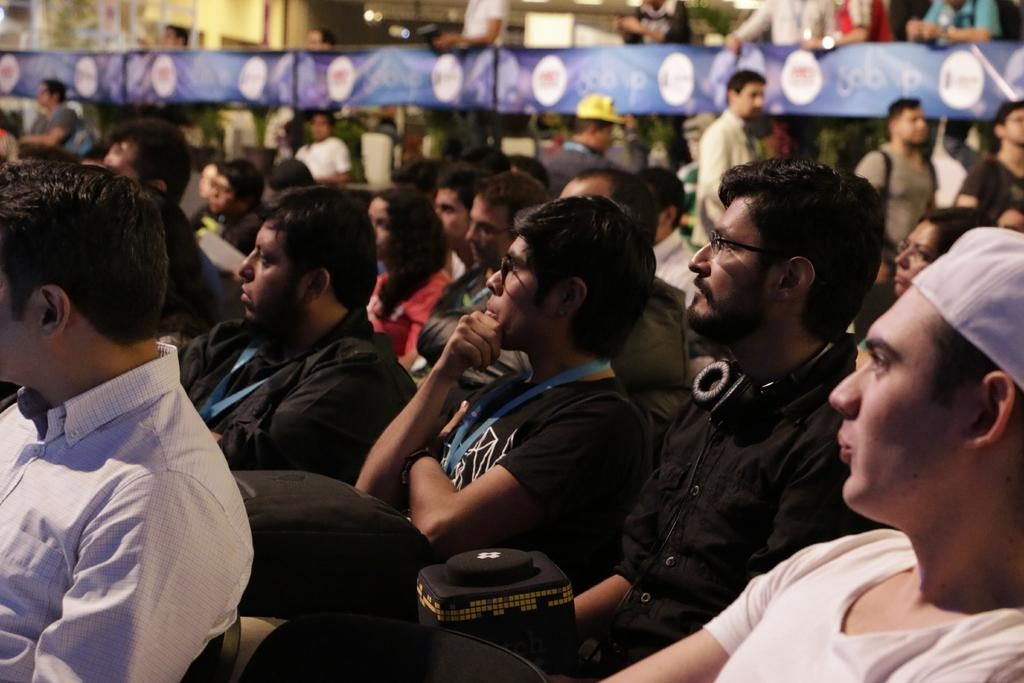What are the people in the image doing? There is a group of people sitting in the image. How are the people dressed? The people are wearing different dress. What can be seen in the background of the image? There are blue banners visible in the background. Are there any other people in the image besides those sitting? Yes, there are people standing in the background. What type of bean is being served on the table in the image? There is no bean present in the image; it features a group of people sitting and wearing different dress, with blue banners in the background. How many elbows can be seen in the image? It is not possible to count elbows in the image, as the focus is on the people sitting and their clothing, as well as the blue banners in the background. 